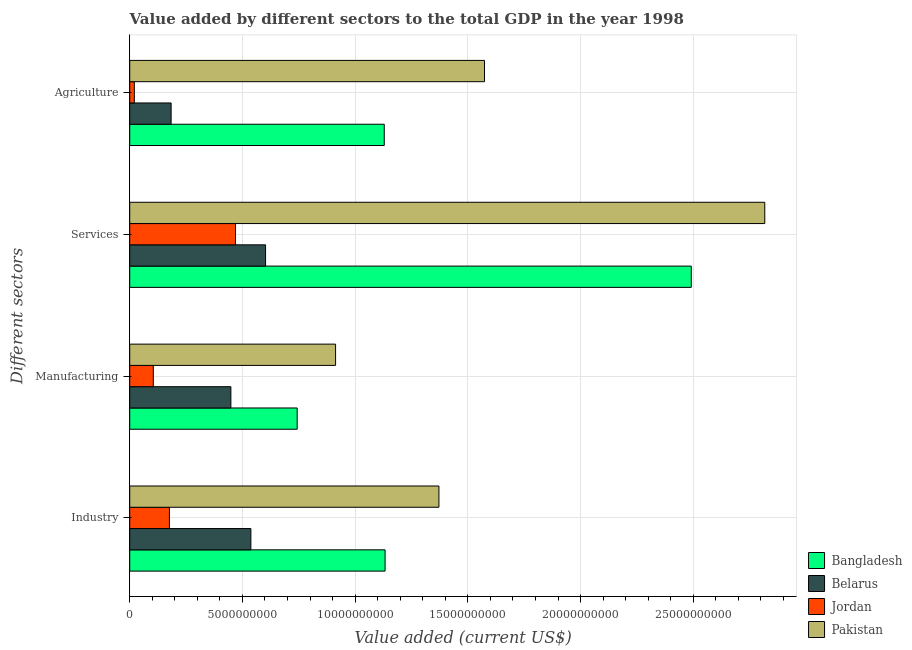How many groups of bars are there?
Keep it short and to the point. 4. How many bars are there on the 3rd tick from the top?
Keep it short and to the point. 4. How many bars are there on the 4th tick from the bottom?
Provide a succinct answer. 4. What is the label of the 2nd group of bars from the top?
Provide a short and direct response. Services. What is the value added by agricultural sector in Pakistan?
Keep it short and to the point. 1.57e+1. Across all countries, what is the maximum value added by manufacturing sector?
Provide a short and direct response. 9.13e+09. Across all countries, what is the minimum value added by agricultural sector?
Your response must be concise. 2.04e+08. In which country was the value added by industrial sector maximum?
Your answer should be compact. Pakistan. In which country was the value added by manufacturing sector minimum?
Make the answer very short. Jordan. What is the total value added by industrial sector in the graph?
Offer a very short reply. 3.22e+1. What is the difference between the value added by agricultural sector in Belarus and that in Pakistan?
Your answer should be compact. -1.39e+1. What is the difference between the value added by services sector in Belarus and the value added by agricultural sector in Pakistan?
Offer a very short reply. -9.71e+09. What is the average value added by agricultural sector per country?
Your answer should be compact. 7.27e+09. What is the difference between the value added by agricultural sector and value added by services sector in Pakistan?
Your answer should be compact. -1.24e+1. In how many countries, is the value added by industrial sector greater than 14000000000 US$?
Offer a terse response. 0. What is the ratio of the value added by manufacturing sector in Pakistan to that in Bangladesh?
Offer a very short reply. 1.23. Is the value added by industrial sector in Jordan less than that in Pakistan?
Provide a short and direct response. Yes. What is the difference between the highest and the second highest value added by agricultural sector?
Provide a short and direct response. 4.45e+09. What is the difference between the highest and the lowest value added by manufacturing sector?
Your answer should be very brief. 8.08e+09. What does the 3rd bar from the bottom in Manufacturing represents?
Your answer should be compact. Jordan. Is it the case that in every country, the sum of the value added by industrial sector and value added by manufacturing sector is greater than the value added by services sector?
Your answer should be compact. No. Are the values on the major ticks of X-axis written in scientific E-notation?
Offer a terse response. No. Does the graph contain grids?
Keep it short and to the point. Yes. How many legend labels are there?
Keep it short and to the point. 4. How are the legend labels stacked?
Provide a succinct answer. Vertical. What is the title of the graph?
Make the answer very short. Value added by different sectors to the total GDP in the year 1998. Does "Kiribati" appear as one of the legend labels in the graph?
Keep it short and to the point. No. What is the label or title of the X-axis?
Provide a short and direct response. Value added (current US$). What is the label or title of the Y-axis?
Offer a terse response. Different sectors. What is the Value added (current US$) in Bangladesh in Industry?
Provide a short and direct response. 1.13e+1. What is the Value added (current US$) of Belarus in Industry?
Your response must be concise. 5.37e+09. What is the Value added (current US$) of Jordan in Industry?
Offer a very short reply. 1.76e+09. What is the Value added (current US$) of Pakistan in Industry?
Provide a short and direct response. 1.37e+1. What is the Value added (current US$) in Bangladesh in Manufacturing?
Offer a terse response. 7.43e+09. What is the Value added (current US$) in Belarus in Manufacturing?
Make the answer very short. 4.49e+09. What is the Value added (current US$) in Jordan in Manufacturing?
Make the answer very short. 1.05e+09. What is the Value added (current US$) in Pakistan in Manufacturing?
Provide a short and direct response. 9.13e+09. What is the Value added (current US$) in Bangladesh in Services?
Make the answer very short. 2.49e+1. What is the Value added (current US$) of Belarus in Services?
Keep it short and to the point. 6.03e+09. What is the Value added (current US$) in Jordan in Services?
Your answer should be very brief. 4.69e+09. What is the Value added (current US$) in Pakistan in Services?
Make the answer very short. 2.82e+1. What is the Value added (current US$) in Bangladesh in Agriculture?
Ensure brevity in your answer.  1.13e+1. What is the Value added (current US$) of Belarus in Agriculture?
Your response must be concise. 1.84e+09. What is the Value added (current US$) in Jordan in Agriculture?
Give a very brief answer. 2.04e+08. What is the Value added (current US$) in Pakistan in Agriculture?
Ensure brevity in your answer.  1.57e+1. Across all Different sectors, what is the maximum Value added (current US$) of Bangladesh?
Offer a very short reply. 2.49e+1. Across all Different sectors, what is the maximum Value added (current US$) in Belarus?
Your answer should be compact. 6.03e+09. Across all Different sectors, what is the maximum Value added (current US$) of Jordan?
Make the answer very short. 4.69e+09. Across all Different sectors, what is the maximum Value added (current US$) of Pakistan?
Ensure brevity in your answer.  2.82e+1. Across all Different sectors, what is the minimum Value added (current US$) in Bangladesh?
Offer a very short reply. 7.43e+09. Across all Different sectors, what is the minimum Value added (current US$) of Belarus?
Your answer should be compact. 1.84e+09. Across all Different sectors, what is the minimum Value added (current US$) in Jordan?
Give a very brief answer. 2.04e+08. Across all Different sectors, what is the minimum Value added (current US$) of Pakistan?
Your answer should be very brief. 9.13e+09. What is the total Value added (current US$) in Bangladesh in the graph?
Make the answer very short. 5.50e+1. What is the total Value added (current US$) in Belarus in the graph?
Your answer should be very brief. 1.77e+1. What is the total Value added (current US$) of Jordan in the graph?
Make the answer very short. 7.70e+09. What is the total Value added (current US$) in Pakistan in the graph?
Offer a very short reply. 6.68e+1. What is the difference between the Value added (current US$) in Bangladesh in Industry and that in Manufacturing?
Your response must be concise. 3.90e+09. What is the difference between the Value added (current US$) in Belarus in Industry and that in Manufacturing?
Ensure brevity in your answer.  8.87e+08. What is the difference between the Value added (current US$) in Jordan in Industry and that in Manufacturing?
Your response must be concise. 7.14e+08. What is the difference between the Value added (current US$) in Pakistan in Industry and that in Manufacturing?
Offer a very short reply. 4.58e+09. What is the difference between the Value added (current US$) of Bangladesh in Industry and that in Services?
Your answer should be very brief. -1.36e+1. What is the difference between the Value added (current US$) in Belarus in Industry and that in Services?
Keep it short and to the point. -6.51e+08. What is the difference between the Value added (current US$) in Jordan in Industry and that in Services?
Keep it short and to the point. -2.93e+09. What is the difference between the Value added (current US$) in Pakistan in Industry and that in Services?
Your answer should be very brief. -1.45e+1. What is the difference between the Value added (current US$) in Bangladesh in Industry and that in Agriculture?
Your response must be concise. 3.67e+07. What is the difference between the Value added (current US$) of Belarus in Industry and that in Agriculture?
Provide a succinct answer. 3.54e+09. What is the difference between the Value added (current US$) of Jordan in Industry and that in Agriculture?
Ensure brevity in your answer.  1.56e+09. What is the difference between the Value added (current US$) in Pakistan in Industry and that in Agriculture?
Provide a succinct answer. -2.02e+09. What is the difference between the Value added (current US$) of Bangladesh in Manufacturing and that in Services?
Provide a short and direct response. -1.75e+1. What is the difference between the Value added (current US$) of Belarus in Manufacturing and that in Services?
Your answer should be compact. -1.54e+09. What is the difference between the Value added (current US$) in Jordan in Manufacturing and that in Services?
Make the answer very short. -3.65e+09. What is the difference between the Value added (current US$) of Pakistan in Manufacturing and that in Services?
Keep it short and to the point. -1.90e+1. What is the difference between the Value added (current US$) of Bangladesh in Manufacturing and that in Agriculture?
Your response must be concise. -3.86e+09. What is the difference between the Value added (current US$) in Belarus in Manufacturing and that in Agriculture?
Your answer should be very brief. 2.65e+09. What is the difference between the Value added (current US$) in Jordan in Manufacturing and that in Agriculture?
Your answer should be compact. 8.42e+08. What is the difference between the Value added (current US$) of Pakistan in Manufacturing and that in Agriculture?
Your response must be concise. -6.61e+09. What is the difference between the Value added (current US$) of Bangladesh in Services and that in Agriculture?
Give a very brief answer. 1.36e+1. What is the difference between the Value added (current US$) in Belarus in Services and that in Agriculture?
Offer a very short reply. 4.19e+09. What is the difference between the Value added (current US$) of Jordan in Services and that in Agriculture?
Offer a very short reply. 4.49e+09. What is the difference between the Value added (current US$) of Pakistan in Services and that in Agriculture?
Your answer should be very brief. 1.24e+1. What is the difference between the Value added (current US$) in Bangladesh in Industry and the Value added (current US$) in Belarus in Manufacturing?
Your response must be concise. 6.84e+09. What is the difference between the Value added (current US$) in Bangladesh in Industry and the Value added (current US$) in Jordan in Manufacturing?
Ensure brevity in your answer.  1.03e+1. What is the difference between the Value added (current US$) in Bangladesh in Industry and the Value added (current US$) in Pakistan in Manufacturing?
Provide a succinct answer. 2.20e+09. What is the difference between the Value added (current US$) of Belarus in Industry and the Value added (current US$) of Jordan in Manufacturing?
Make the answer very short. 4.33e+09. What is the difference between the Value added (current US$) in Belarus in Industry and the Value added (current US$) in Pakistan in Manufacturing?
Give a very brief answer. -3.76e+09. What is the difference between the Value added (current US$) of Jordan in Industry and the Value added (current US$) of Pakistan in Manufacturing?
Ensure brevity in your answer.  -7.37e+09. What is the difference between the Value added (current US$) of Bangladesh in Industry and the Value added (current US$) of Belarus in Services?
Provide a succinct answer. 5.30e+09. What is the difference between the Value added (current US$) of Bangladesh in Industry and the Value added (current US$) of Jordan in Services?
Keep it short and to the point. 6.63e+09. What is the difference between the Value added (current US$) in Bangladesh in Industry and the Value added (current US$) in Pakistan in Services?
Keep it short and to the point. -1.68e+1. What is the difference between the Value added (current US$) in Belarus in Industry and the Value added (current US$) in Jordan in Services?
Offer a terse response. 6.81e+08. What is the difference between the Value added (current US$) of Belarus in Industry and the Value added (current US$) of Pakistan in Services?
Ensure brevity in your answer.  -2.28e+1. What is the difference between the Value added (current US$) of Jordan in Industry and the Value added (current US$) of Pakistan in Services?
Give a very brief answer. -2.64e+1. What is the difference between the Value added (current US$) in Bangladesh in Industry and the Value added (current US$) in Belarus in Agriculture?
Your answer should be compact. 9.49e+09. What is the difference between the Value added (current US$) in Bangladesh in Industry and the Value added (current US$) in Jordan in Agriculture?
Offer a terse response. 1.11e+1. What is the difference between the Value added (current US$) in Bangladesh in Industry and the Value added (current US$) in Pakistan in Agriculture?
Ensure brevity in your answer.  -4.41e+09. What is the difference between the Value added (current US$) of Belarus in Industry and the Value added (current US$) of Jordan in Agriculture?
Offer a terse response. 5.17e+09. What is the difference between the Value added (current US$) of Belarus in Industry and the Value added (current US$) of Pakistan in Agriculture?
Offer a very short reply. -1.04e+1. What is the difference between the Value added (current US$) in Jordan in Industry and the Value added (current US$) in Pakistan in Agriculture?
Make the answer very short. -1.40e+1. What is the difference between the Value added (current US$) in Bangladesh in Manufacturing and the Value added (current US$) in Belarus in Services?
Your response must be concise. 1.40e+09. What is the difference between the Value added (current US$) of Bangladesh in Manufacturing and the Value added (current US$) of Jordan in Services?
Provide a succinct answer. 2.73e+09. What is the difference between the Value added (current US$) of Bangladesh in Manufacturing and the Value added (current US$) of Pakistan in Services?
Provide a succinct answer. -2.07e+1. What is the difference between the Value added (current US$) in Belarus in Manufacturing and the Value added (current US$) in Jordan in Services?
Ensure brevity in your answer.  -2.06e+08. What is the difference between the Value added (current US$) in Belarus in Manufacturing and the Value added (current US$) in Pakistan in Services?
Provide a succinct answer. -2.37e+1. What is the difference between the Value added (current US$) of Jordan in Manufacturing and the Value added (current US$) of Pakistan in Services?
Provide a succinct answer. -2.71e+1. What is the difference between the Value added (current US$) of Bangladesh in Manufacturing and the Value added (current US$) of Belarus in Agriculture?
Offer a terse response. 5.59e+09. What is the difference between the Value added (current US$) of Bangladesh in Manufacturing and the Value added (current US$) of Jordan in Agriculture?
Ensure brevity in your answer.  7.22e+09. What is the difference between the Value added (current US$) in Bangladesh in Manufacturing and the Value added (current US$) in Pakistan in Agriculture?
Give a very brief answer. -8.31e+09. What is the difference between the Value added (current US$) in Belarus in Manufacturing and the Value added (current US$) in Jordan in Agriculture?
Provide a short and direct response. 4.28e+09. What is the difference between the Value added (current US$) of Belarus in Manufacturing and the Value added (current US$) of Pakistan in Agriculture?
Ensure brevity in your answer.  -1.12e+1. What is the difference between the Value added (current US$) in Jordan in Manufacturing and the Value added (current US$) in Pakistan in Agriculture?
Provide a short and direct response. -1.47e+1. What is the difference between the Value added (current US$) in Bangladesh in Services and the Value added (current US$) in Belarus in Agriculture?
Give a very brief answer. 2.31e+1. What is the difference between the Value added (current US$) in Bangladesh in Services and the Value added (current US$) in Jordan in Agriculture?
Keep it short and to the point. 2.47e+1. What is the difference between the Value added (current US$) in Bangladesh in Services and the Value added (current US$) in Pakistan in Agriculture?
Your answer should be very brief. 9.17e+09. What is the difference between the Value added (current US$) in Belarus in Services and the Value added (current US$) in Jordan in Agriculture?
Your answer should be very brief. 5.82e+09. What is the difference between the Value added (current US$) in Belarus in Services and the Value added (current US$) in Pakistan in Agriculture?
Make the answer very short. -9.71e+09. What is the difference between the Value added (current US$) in Jordan in Services and the Value added (current US$) in Pakistan in Agriculture?
Provide a short and direct response. -1.10e+1. What is the average Value added (current US$) of Bangladesh per Different sectors?
Offer a terse response. 1.37e+1. What is the average Value added (current US$) in Belarus per Different sectors?
Your answer should be very brief. 4.43e+09. What is the average Value added (current US$) of Jordan per Different sectors?
Your answer should be compact. 1.93e+09. What is the average Value added (current US$) of Pakistan per Different sectors?
Offer a very short reply. 1.67e+1. What is the difference between the Value added (current US$) in Bangladesh and Value added (current US$) in Belarus in Industry?
Provide a succinct answer. 5.95e+09. What is the difference between the Value added (current US$) of Bangladesh and Value added (current US$) of Jordan in Industry?
Make the answer very short. 9.57e+09. What is the difference between the Value added (current US$) of Bangladesh and Value added (current US$) of Pakistan in Industry?
Your response must be concise. -2.39e+09. What is the difference between the Value added (current US$) of Belarus and Value added (current US$) of Jordan in Industry?
Provide a succinct answer. 3.61e+09. What is the difference between the Value added (current US$) in Belarus and Value added (current US$) in Pakistan in Industry?
Offer a terse response. -8.34e+09. What is the difference between the Value added (current US$) of Jordan and Value added (current US$) of Pakistan in Industry?
Make the answer very short. -1.20e+1. What is the difference between the Value added (current US$) in Bangladesh and Value added (current US$) in Belarus in Manufacturing?
Offer a terse response. 2.94e+09. What is the difference between the Value added (current US$) of Bangladesh and Value added (current US$) of Jordan in Manufacturing?
Offer a terse response. 6.38e+09. What is the difference between the Value added (current US$) in Bangladesh and Value added (current US$) in Pakistan in Manufacturing?
Provide a succinct answer. -1.70e+09. What is the difference between the Value added (current US$) of Belarus and Value added (current US$) of Jordan in Manufacturing?
Your response must be concise. 3.44e+09. What is the difference between the Value added (current US$) in Belarus and Value added (current US$) in Pakistan in Manufacturing?
Your response must be concise. -4.64e+09. What is the difference between the Value added (current US$) of Jordan and Value added (current US$) of Pakistan in Manufacturing?
Provide a succinct answer. -8.08e+09. What is the difference between the Value added (current US$) of Bangladesh and Value added (current US$) of Belarus in Services?
Offer a very short reply. 1.89e+1. What is the difference between the Value added (current US$) of Bangladesh and Value added (current US$) of Jordan in Services?
Provide a succinct answer. 2.02e+1. What is the difference between the Value added (current US$) in Bangladesh and Value added (current US$) in Pakistan in Services?
Your answer should be compact. -3.26e+09. What is the difference between the Value added (current US$) in Belarus and Value added (current US$) in Jordan in Services?
Give a very brief answer. 1.33e+09. What is the difference between the Value added (current US$) of Belarus and Value added (current US$) of Pakistan in Services?
Your response must be concise. -2.21e+1. What is the difference between the Value added (current US$) of Jordan and Value added (current US$) of Pakistan in Services?
Your answer should be compact. -2.35e+1. What is the difference between the Value added (current US$) of Bangladesh and Value added (current US$) of Belarus in Agriculture?
Offer a terse response. 9.45e+09. What is the difference between the Value added (current US$) in Bangladesh and Value added (current US$) in Jordan in Agriculture?
Your answer should be very brief. 1.11e+1. What is the difference between the Value added (current US$) in Bangladesh and Value added (current US$) in Pakistan in Agriculture?
Give a very brief answer. -4.45e+09. What is the difference between the Value added (current US$) in Belarus and Value added (current US$) in Jordan in Agriculture?
Your response must be concise. 1.63e+09. What is the difference between the Value added (current US$) of Belarus and Value added (current US$) of Pakistan in Agriculture?
Provide a succinct answer. -1.39e+1. What is the difference between the Value added (current US$) in Jordan and Value added (current US$) in Pakistan in Agriculture?
Offer a very short reply. -1.55e+1. What is the ratio of the Value added (current US$) of Bangladesh in Industry to that in Manufacturing?
Keep it short and to the point. 1.52. What is the ratio of the Value added (current US$) in Belarus in Industry to that in Manufacturing?
Give a very brief answer. 1.2. What is the ratio of the Value added (current US$) of Jordan in Industry to that in Manufacturing?
Provide a short and direct response. 1.68. What is the ratio of the Value added (current US$) in Pakistan in Industry to that in Manufacturing?
Give a very brief answer. 1.5. What is the ratio of the Value added (current US$) of Bangladesh in Industry to that in Services?
Make the answer very short. 0.45. What is the ratio of the Value added (current US$) of Belarus in Industry to that in Services?
Provide a succinct answer. 0.89. What is the ratio of the Value added (current US$) in Jordan in Industry to that in Services?
Provide a short and direct response. 0.38. What is the ratio of the Value added (current US$) of Pakistan in Industry to that in Services?
Give a very brief answer. 0.49. What is the ratio of the Value added (current US$) of Bangladesh in Industry to that in Agriculture?
Offer a very short reply. 1. What is the ratio of the Value added (current US$) of Belarus in Industry to that in Agriculture?
Keep it short and to the point. 2.93. What is the ratio of the Value added (current US$) of Jordan in Industry to that in Agriculture?
Offer a terse response. 8.63. What is the ratio of the Value added (current US$) in Pakistan in Industry to that in Agriculture?
Keep it short and to the point. 0.87. What is the ratio of the Value added (current US$) in Bangladesh in Manufacturing to that in Services?
Your answer should be very brief. 0.3. What is the ratio of the Value added (current US$) of Belarus in Manufacturing to that in Services?
Your answer should be very brief. 0.74. What is the ratio of the Value added (current US$) of Jordan in Manufacturing to that in Services?
Give a very brief answer. 0.22. What is the ratio of the Value added (current US$) of Pakistan in Manufacturing to that in Services?
Ensure brevity in your answer.  0.32. What is the ratio of the Value added (current US$) in Bangladesh in Manufacturing to that in Agriculture?
Keep it short and to the point. 0.66. What is the ratio of the Value added (current US$) of Belarus in Manufacturing to that in Agriculture?
Provide a succinct answer. 2.44. What is the ratio of the Value added (current US$) in Jordan in Manufacturing to that in Agriculture?
Provide a succinct answer. 5.13. What is the ratio of the Value added (current US$) in Pakistan in Manufacturing to that in Agriculture?
Keep it short and to the point. 0.58. What is the ratio of the Value added (current US$) in Bangladesh in Services to that in Agriculture?
Provide a short and direct response. 2.21. What is the ratio of the Value added (current US$) in Belarus in Services to that in Agriculture?
Make the answer very short. 3.28. What is the ratio of the Value added (current US$) in Jordan in Services to that in Agriculture?
Make the answer very short. 23. What is the ratio of the Value added (current US$) of Pakistan in Services to that in Agriculture?
Provide a short and direct response. 1.79. What is the difference between the highest and the second highest Value added (current US$) of Bangladesh?
Your response must be concise. 1.36e+1. What is the difference between the highest and the second highest Value added (current US$) of Belarus?
Keep it short and to the point. 6.51e+08. What is the difference between the highest and the second highest Value added (current US$) of Jordan?
Offer a terse response. 2.93e+09. What is the difference between the highest and the second highest Value added (current US$) of Pakistan?
Your answer should be compact. 1.24e+1. What is the difference between the highest and the lowest Value added (current US$) of Bangladesh?
Your response must be concise. 1.75e+1. What is the difference between the highest and the lowest Value added (current US$) of Belarus?
Offer a very short reply. 4.19e+09. What is the difference between the highest and the lowest Value added (current US$) of Jordan?
Keep it short and to the point. 4.49e+09. What is the difference between the highest and the lowest Value added (current US$) in Pakistan?
Make the answer very short. 1.90e+1. 